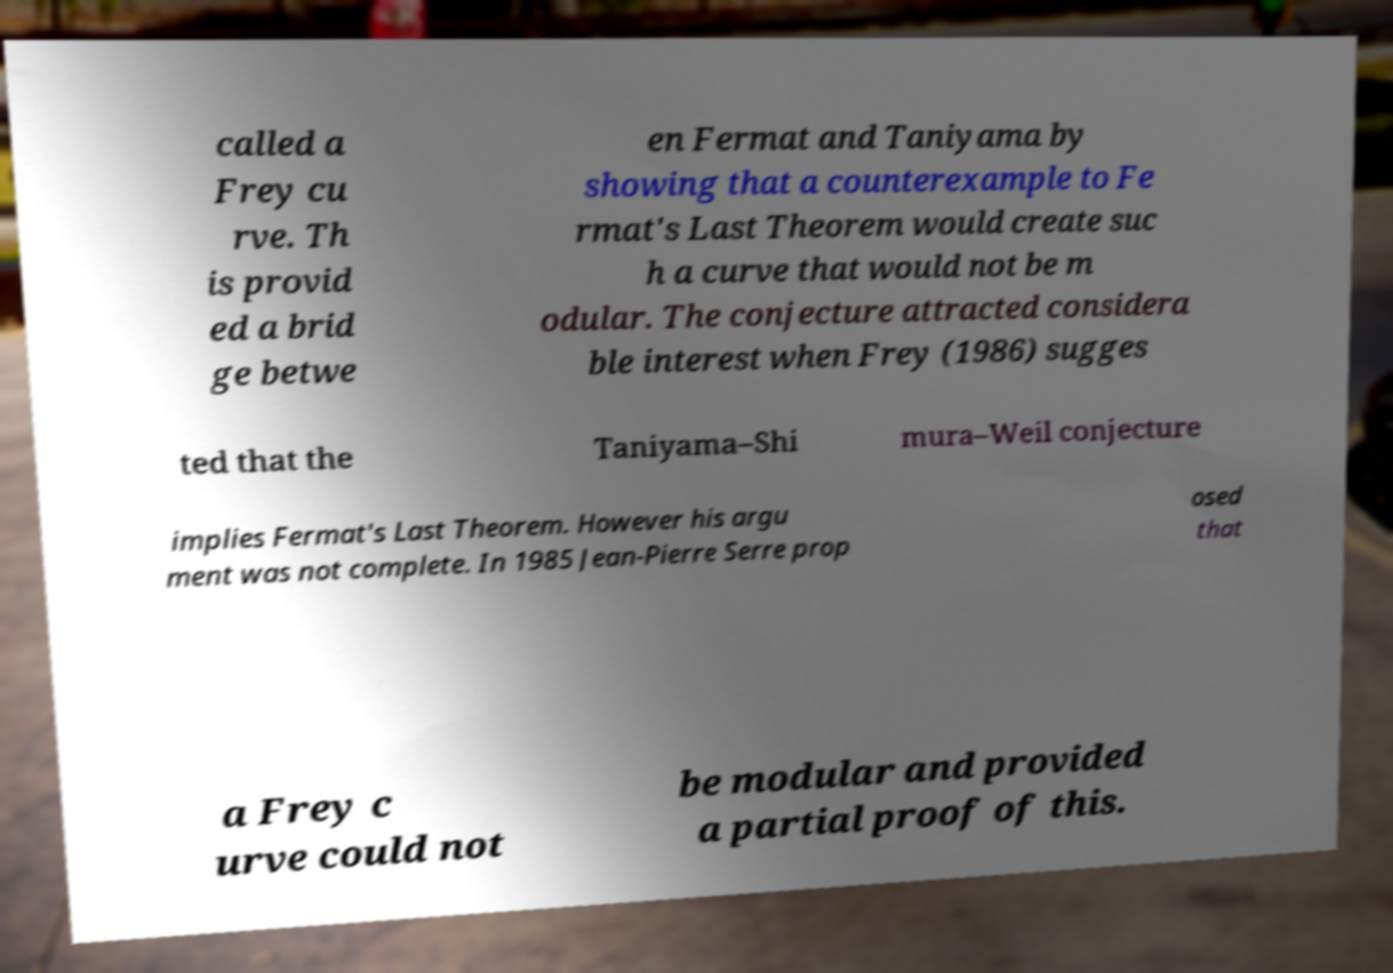I need the written content from this picture converted into text. Can you do that? called a Frey cu rve. Th is provid ed a brid ge betwe en Fermat and Taniyama by showing that a counterexample to Fe rmat's Last Theorem would create suc h a curve that would not be m odular. The conjecture attracted considera ble interest when Frey (1986) sugges ted that the Taniyama–Shi mura–Weil conjecture implies Fermat's Last Theorem. However his argu ment was not complete. In 1985 Jean-Pierre Serre prop osed that a Frey c urve could not be modular and provided a partial proof of this. 